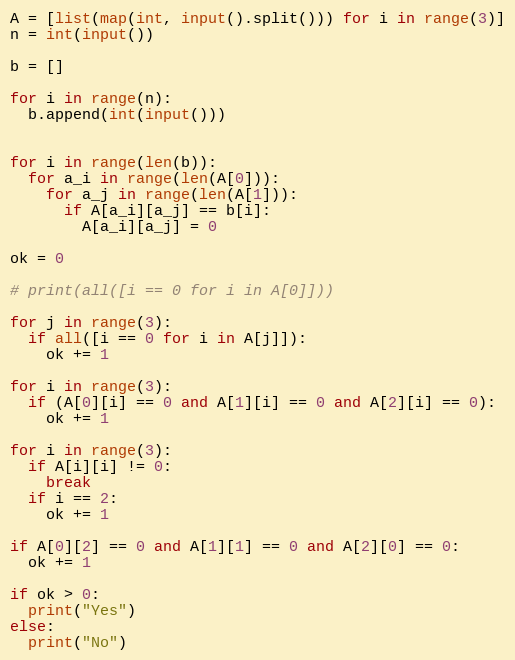Convert code to text. <code><loc_0><loc_0><loc_500><loc_500><_Python_>A = [list(map(int, input().split())) for i in range(3)]
n = int(input())

b = []

for i in range(n):
  b.append(int(input()))


for i in range(len(b)):
  for a_i in range(len(A[0])):
    for a_j in range(len(A[1])):
      if A[a_i][a_j] == b[i]:
        A[a_i][a_j] = 0

ok = 0

# print(all([i == 0 for i in A[0]]))

for j in range(3):
  if all([i == 0 for i in A[j]]):
    ok += 1

for i in range(3):
  if (A[0][i] == 0 and A[1][i] == 0 and A[2][i] == 0):
    ok += 1

for i in range(3):
  if A[i][i] != 0:
    break
  if i == 2:
    ok += 1

if A[0][2] == 0 and A[1][1] == 0 and A[2][0] == 0:
  ok += 1

if ok > 0:
  print("Yes")
else:
  print("No")


</code> 